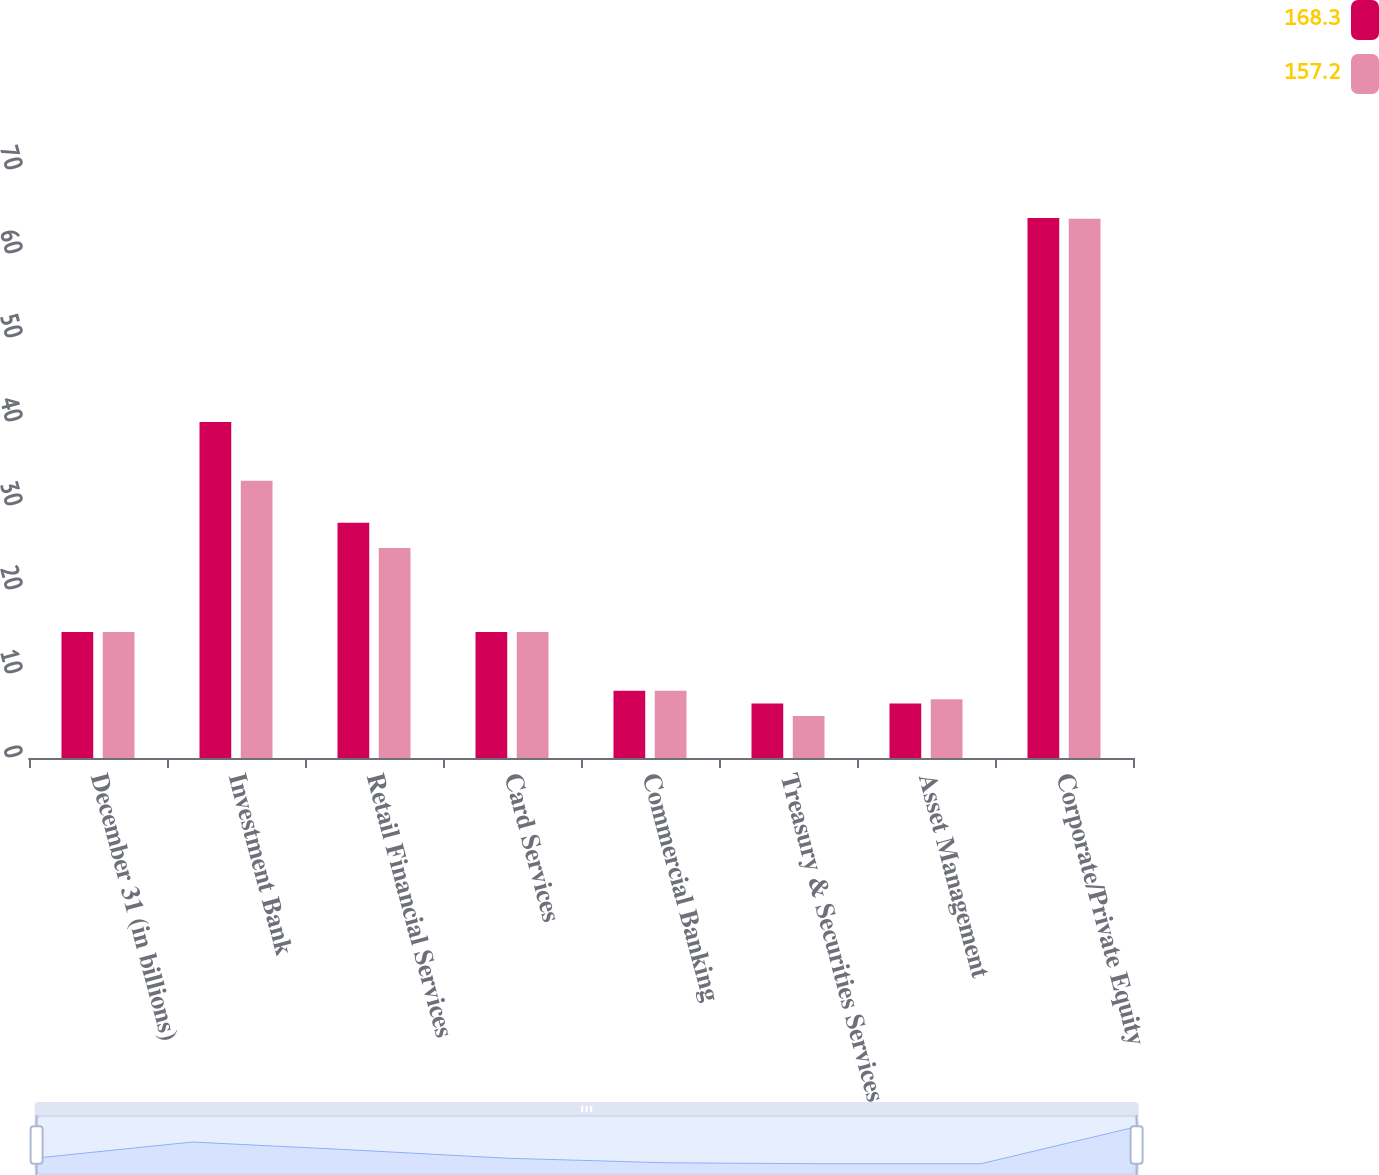<chart> <loc_0><loc_0><loc_500><loc_500><stacked_bar_chart><ecel><fcel>December 31 (in billions)<fcel>Investment Bank<fcel>Retail Financial Services<fcel>Card Services<fcel>Commercial Banking<fcel>Treasury & Securities Services<fcel>Asset Management<fcel>Corporate/Private Equity<nl><fcel>168.3<fcel>15<fcel>40<fcel>28<fcel>15<fcel>8<fcel>6.5<fcel>6.5<fcel>64.3<nl><fcel>157.2<fcel>15<fcel>33<fcel>25<fcel>15<fcel>8<fcel>5<fcel>7<fcel>64.2<nl></chart> 